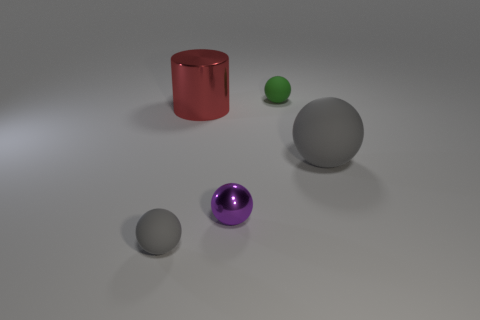Subtract 1 spheres. How many spheres are left? 3 Add 4 matte cylinders. How many objects exist? 9 Subtract all green balls. How many balls are left? 3 Subtract all green balls. How many balls are left? 3 Subtract all brown spheres. Subtract all blue cubes. How many spheres are left? 4 Subtract all spheres. How many objects are left? 1 Subtract all cyan shiny balls. Subtract all gray rubber things. How many objects are left? 3 Add 4 tiny matte things. How many tiny matte things are left? 6 Add 5 gray spheres. How many gray spheres exist? 7 Subtract 0 purple blocks. How many objects are left? 5 